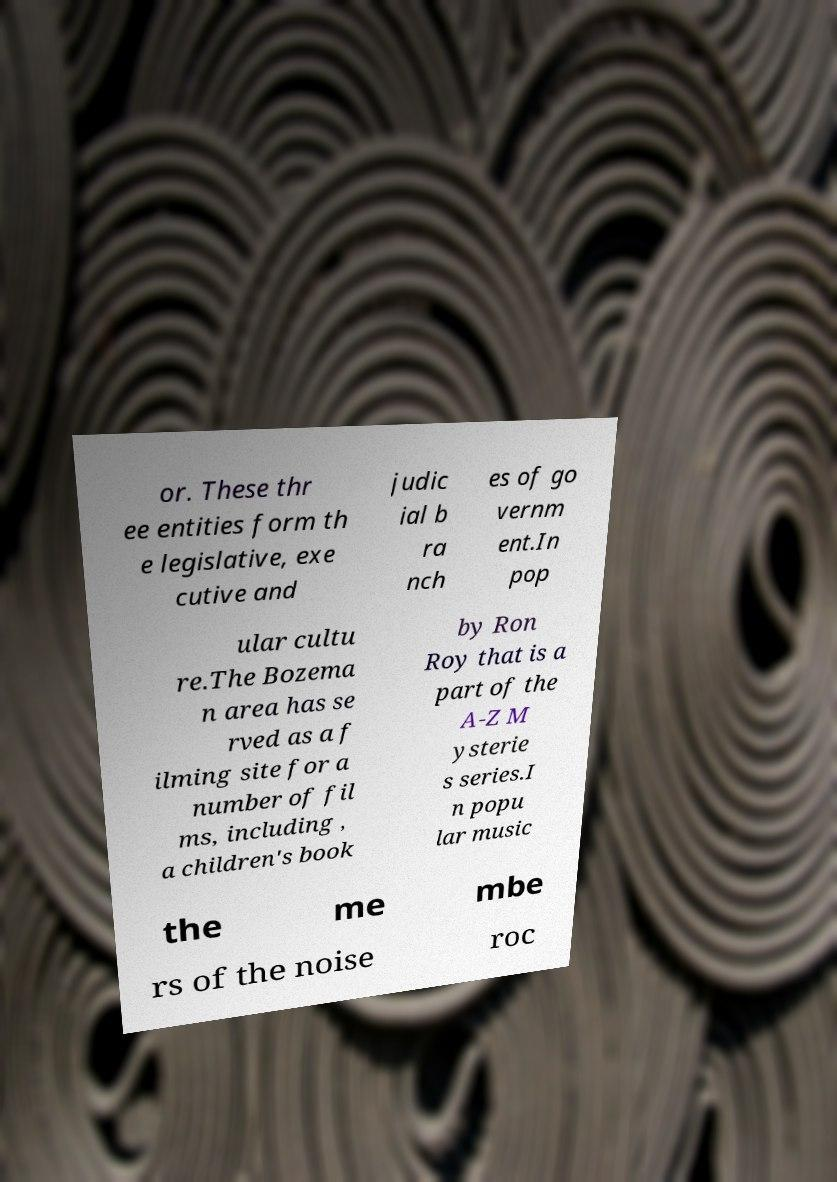There's text embedded in this image that I need extracted. Can you transcribe it verbatim? or. These thr ee entities form th e legislative, exe cutive and judic ial b ra nch es of go vernm ent.In pop ular cultu re.The Bozema n area has se rved as a f ilming site for a number of fil ms, including , a children's book by Ron Roy that is a part of the A-Z M ysterie s series.I n popu lar music the me mbe rs of the noise roc 